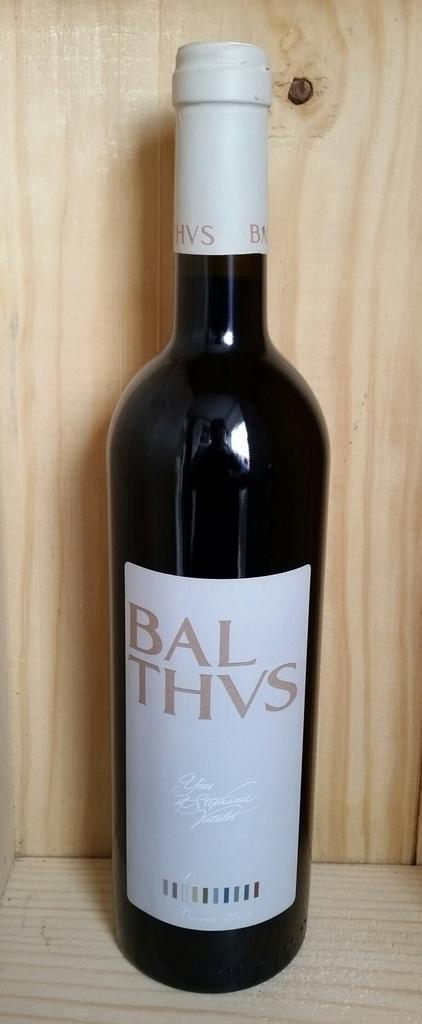<image>
Provide a brief description of the given image. A dark colored bottle of BAL THVS wine with a gold lettered white label and white capping. 